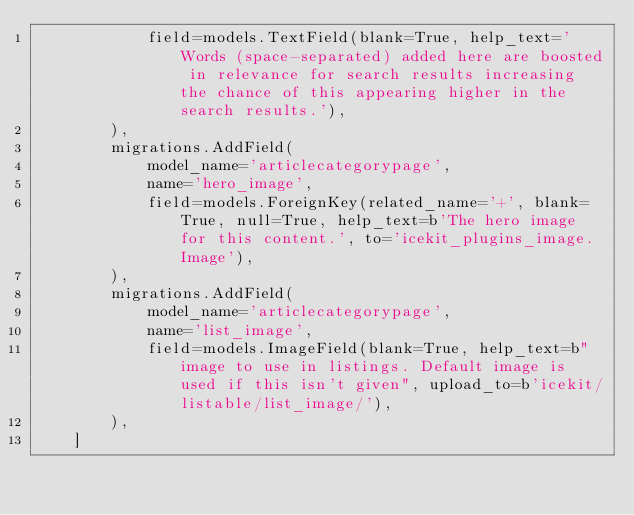Convert code to text. <code><loc_0><loc_0><loc_500><loc_500><_Python_>            field=models.TextField(blank=True, help_text='Words (space-separated) added here are boosted in relevance for search results increasing the chance of this appearing higher in the search results.'),
        ),
        migrations.AddField(
            model_name='articlecategorypage',
            name='hero_image',
            field=models.ForeignKey(related_name='+', blank=True, null=True, help_text=b'The hero image for this content.', to='icekit_plugins_image.Image'),
        ),
        migrations.AddField(
            model_name='articlecategorypage',
            name='list_image',
            field=models.ImageField(blank=True, help_text=b"image to use in listings. Default image is used if this isn't given", upload_to=b'icekit/listable/list_image/'),
        ),
    ]
</code> 